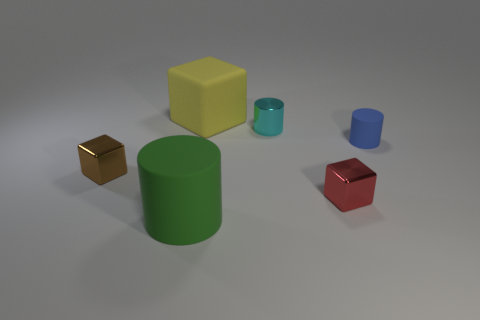Subtract all tiny blocks. How many blocks are left? 1 Subtract 1 cylinders. How many cylinders are left? 2 Add 3 small cyan matte balls. How many objects exist? 9 Add 6 red cubes. How many red cubes are left? 7 Add 3 large rubber cylinders. How many large rubber cylinders exist? 4 Subtract 0 yellow balls. How many objects are left? 6 Subtract all tiny red shiny blocks. Subtract all small red metal cylinders. How many objects are left? 5 